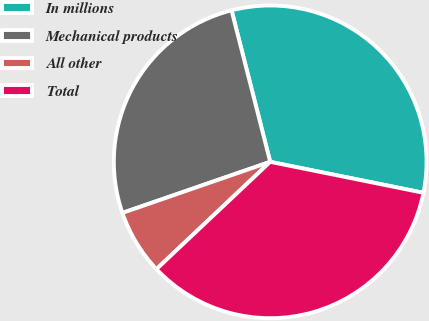<chart> <loc_0><loc_0><loc_500><loc_500><pie_chart><fcel>In millions<fcel>Mechanical products<fcel>All other<fcel>Total<nl><fcel>32.15%<fcel>26.32%<fcel>6.74%<fcel>34.79%<nl></chart> 